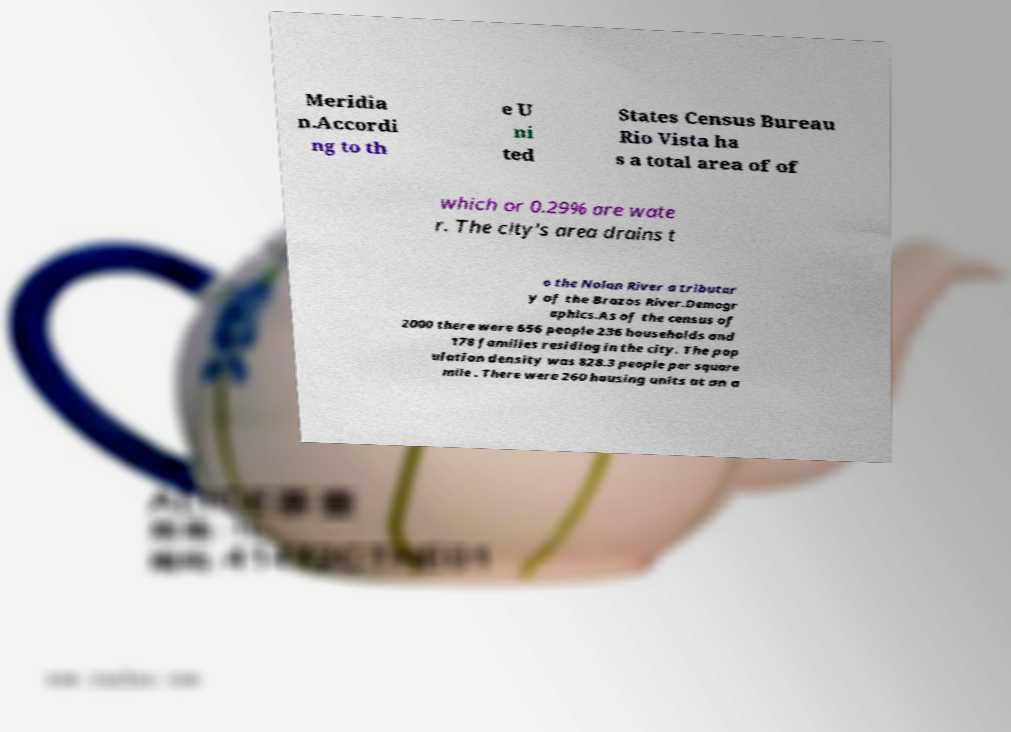I need the written content from this picture converted into text. Can you do that? Meridia n.Accordi ng to th e U ni ted States Census Bureau Rio Vista ha s a total area of of which or 0.29% are wate r. The city's area drains t o the Nolan River a tributar y of the Brazos River.Demogr aphics.As of the census of 2000 there were 656 people 236 households and 178 families residing in the city. The pop ulation density was 828.3 people per square mile . There were 260 housing units at an a 